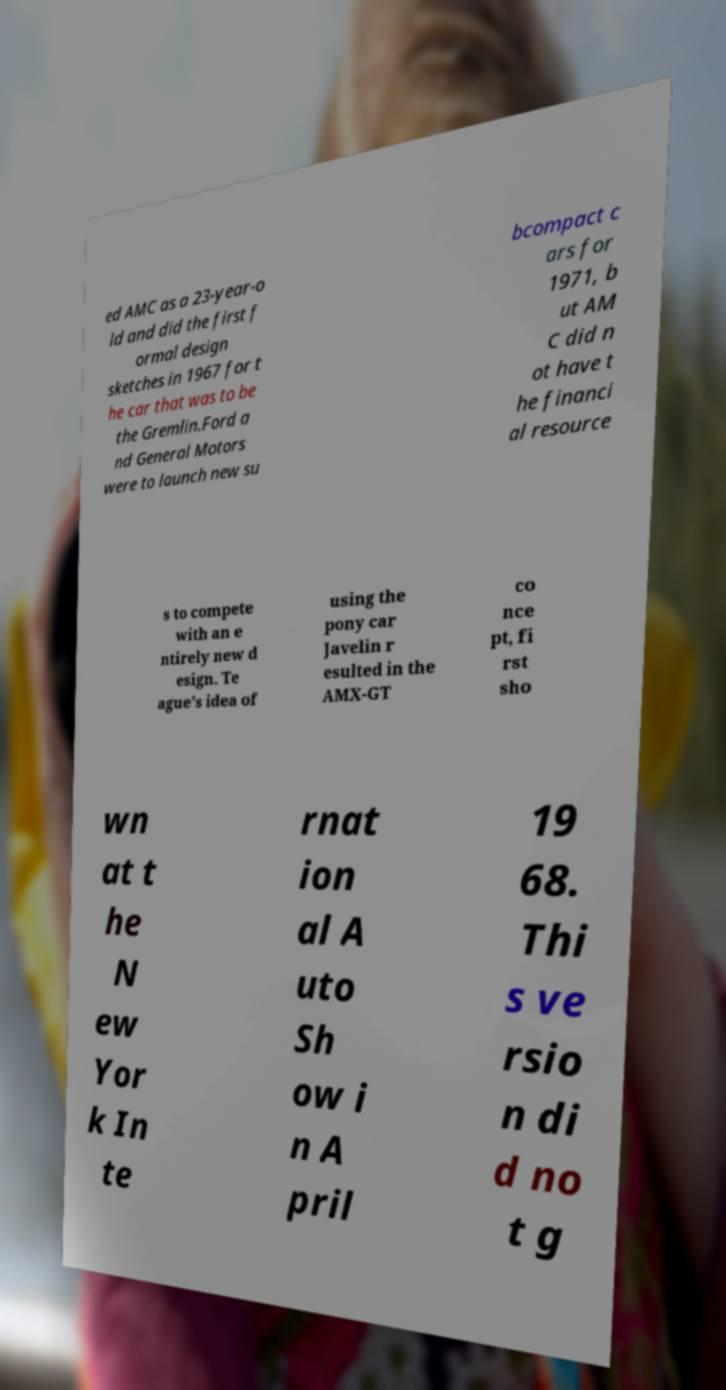What messages or text are displayed in this image? I need them in a readable, typed format. ed AMC as a 23-year-o ld and did the first f ormal design sketches in 1967 for t he car that was to be the Gremlin.Ford a nd General Motors were to launch new su bcompact c ars for 1971, b ut AM C did n ot have t he financi al resource s to compete with an e ntirely new d esign. Te ague's idea of using the pony car Javelin r esulted in the AMX-GT co nce pt, fi rst sho wn at t he N ew Yor k In te rnat ion al A uto Sh ow i n A pril 19 68. Thi s ve rsio n di d no t g 